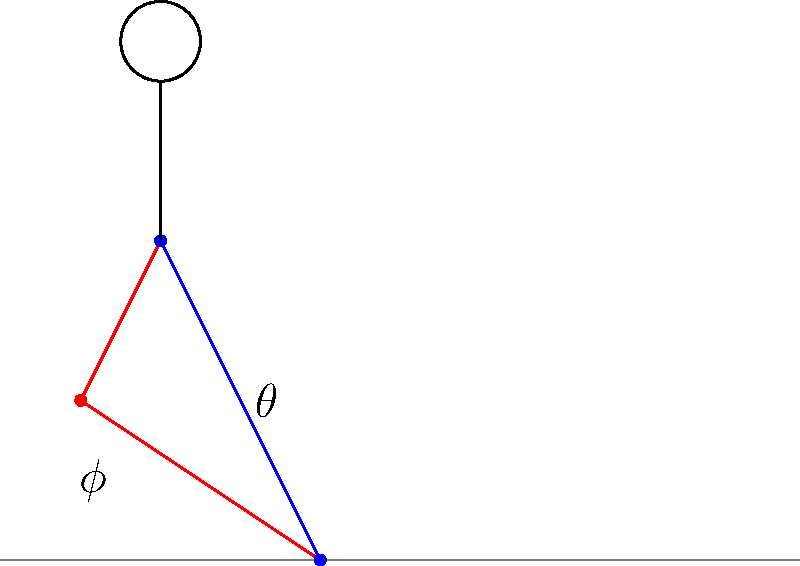In the context of walking biomechanics, consider the stick figure diagram showing a person mid-stride. If the angle $\theta$ represents the angle between the vertical axis and the extended right leg, and $\phi$ represents the angle between the two legs, what is the relationship between these angles when the left foot touches the ground, assuming a symmetric gait on flat terrain? To understand the relationship between angles $\theta$ and $\phi$ in a symmetric gait, let's follow these steps:

1. In a symmetric gait, the motion of both legs is identical but out of phase.

2. When the left foot touches the ground, it will be in the same position as the right foot is now.

3. At that moment, the right leg will be in the position of the current left leg.

4. The angle $\theta$ is currently formed by the right leg with the vertical axis.

5. When the left foot touches the ground, the left leg will form this same angle $\theta$ with the vertical axis.

6. The angle $\phi$ represents the angle between the two legs.

7. In a symmetric gait, when one foot touches the ground, the legs form an isosceles triangle with the ground.

8. In an isosceles triangle, the base angles are equal. Here, both legs will form angle $\theta$ with the vertical.

9. The sum of angles in a triangle is always 180°.

10. Therefore, we can write the equation: $\theta + \theta + \phi = 180°$

11. Simplifying: $2\theta + \phi = 180°$

12. Rearranging: $\phi = 180° - 2\theta$

This equation represents the relationship between $\theta$ and $\phi$ when the left foot touches the ground in a symmetric gait.
Answer: $\phi = 180° - 2\theta$ 